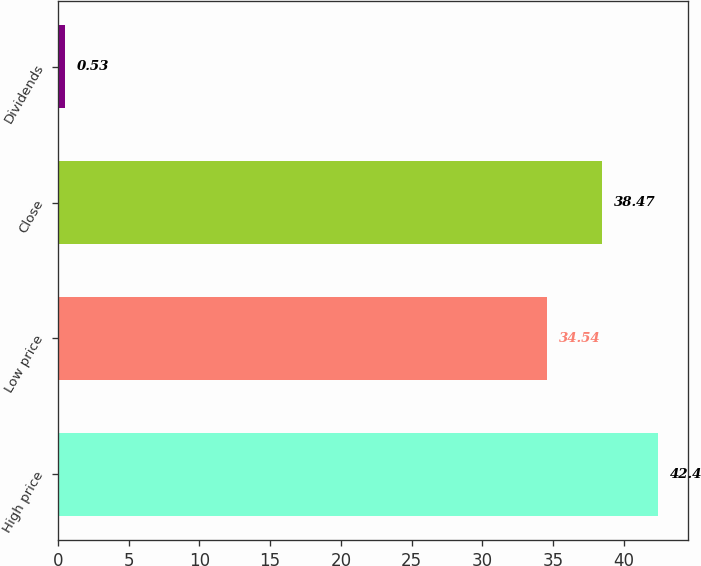Convert chart. <chart><loc_0><loc_0><loc_500><loc_500><bar_chart><fcel>High price<fcel>Low price<fcel>Close<fcel>Dividends<nl><fcel>42.4<fcel>34.54<fcel>38.47<fcel>0.53<nl></chart> 